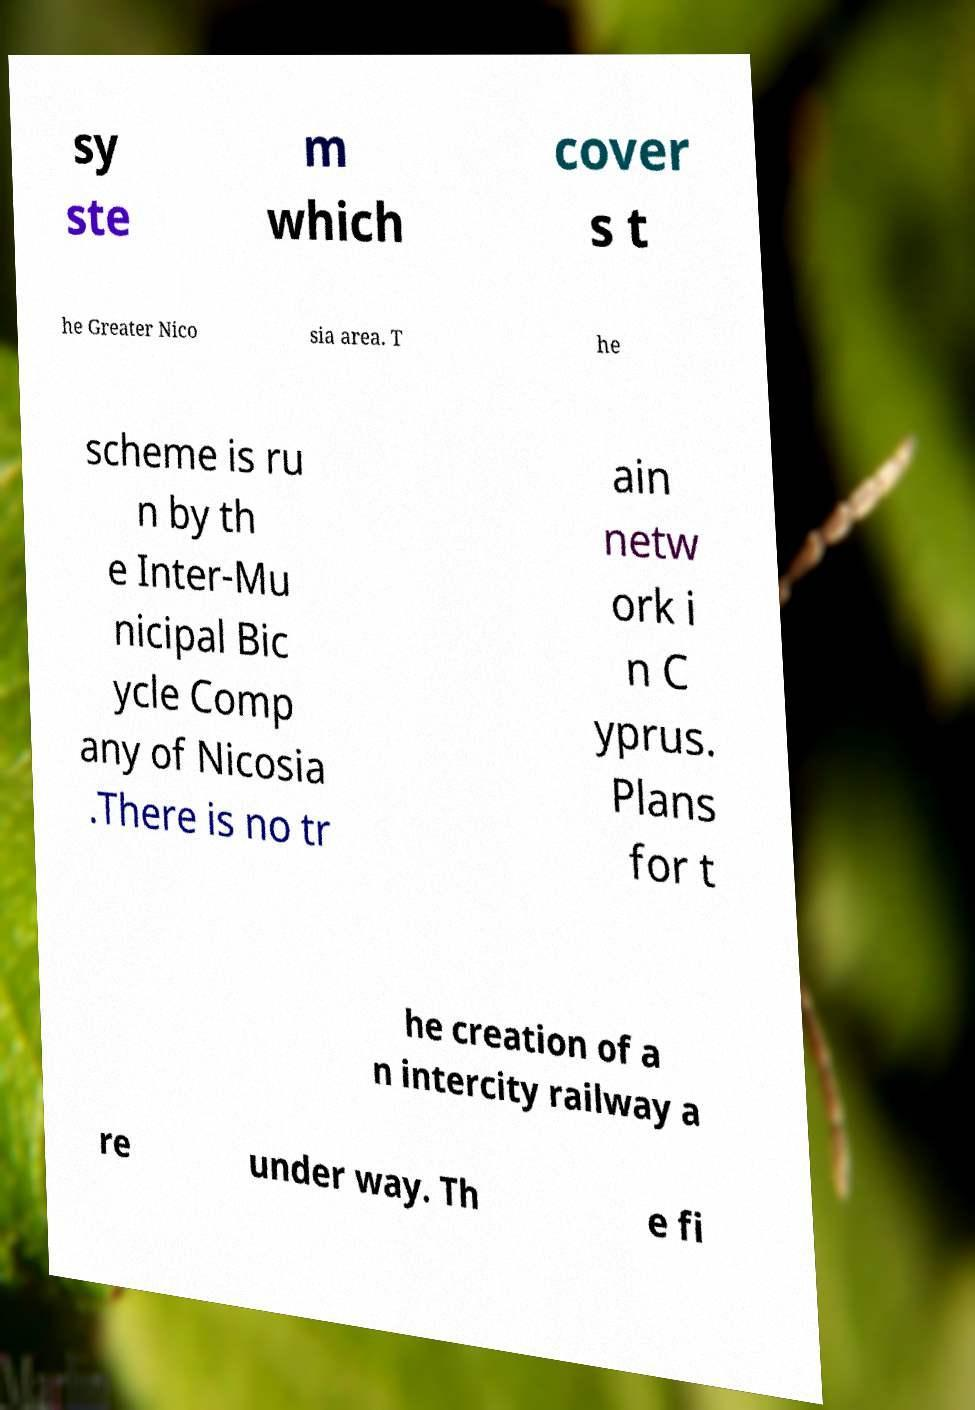Could you assist in decoding the text presented in this image and type it out clearly? sy ste m which cover s t he Greater Nico sia area. T he scheme is ru n by th e Inter-Mu nicipal Bic ycle Comp any of Nicosia .There is no tr ain netw ork i n C yprus. Plans for t he creation of a n intercity railway a re under way. Th e fi 